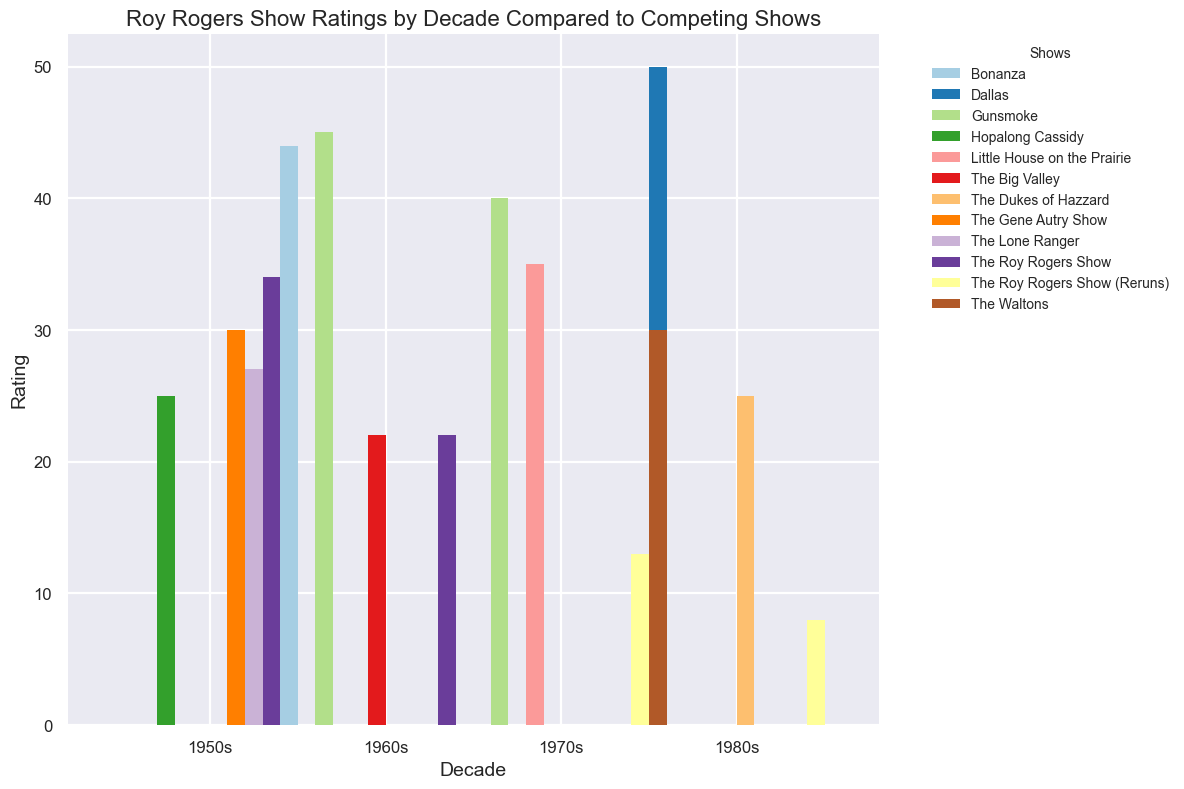Which decade did "The Roy Rogers Show" have its highest rating? The figure shows "The Roy Rogers Show" ratings in different decades. By observing the height of the bars, the highest rating is in the 1950s.
Answer: 1950s How did "The Roy Rogers Show" rating in the 1970s compare to "Little House on the Prairie" in the same decade? Compare the heights of the bars for "The Roy Rogers Show (Reruns)" and "Little House on the Prairie" in the 1970s. The bar for "Little House on the Prairie" is significantly higher.
Answer: Little House on the Prairie had a higher rating What's the total rating of all shows in the 1960s? To find the total, sum the ratings of "The Roy Rogers Show", "Gunsmoke", "Bonanza", and "The Big Valley" in the 1960s. Their respective ratings are 22, 45, 44, and 22. Total = 22 + 45 + 44 + 22 = 133.
Answer: 133 Which show had the highest rating in the 1980s? By comparing the heights of all bars in the 1980s, "Dallas" has the tallest bar, indicating the highest rating.
Answer: Dallas Was there any decade where the rating of "The Roy Rogers Show" was equal to another show in the same decade? Examine the heights of the bars for "The Roy Rogers Show" and compare them with other shows in each decade. In the 1960s, "The Roy Rogers Show" and "The Big Valley" both had a rating of 22.
Answer: Yes, in the 1960s Which decade saw the greatest decline in "The Roy Rogers Show" ratings compared to the previous decade? Calculate the difference in ratings for each decade transition for "The Roy Rogers Show": 1950s to 1960s (34 - 22 = 12), 1960s to 1970s (22 - 13 = 9), and 1970s to 1980s (13 - 8 = 5). The greatest decline is from the 1950s to the 1960s.
Answer: 1950s to 1960s How does the 1980s rating of "The Dukes of Hazzard" compare to the 1960s "Bonanza" rating? Compare the heights of the "The Dukes of Hazzard" bar in the 1980s and the "Bonanza" bar in the 1960s. "Bonanza" in the 1960s is clearly higher than "The Dukes of Hazzard" in the 1980s.
Answer: Bonanza in the 1960s was higher What was the average rating of "The Roy Rogers Show" across the four decades? Add the ratings of "The Roy Rogers Show" for 1950s, 1960s, 1970s, and 1980s; then divide by 4. (34 + 22 + 13 + 8) / 4 = 19.25.
Answer: 19.25 What's the difference in rating between "Gunsmoke" in the 1960s and the 1970s? Subtract the rating of "Gunsmoke" in the 1960s from its rating in the 1970s. 40 - 45 = -5.
Answer: -5 